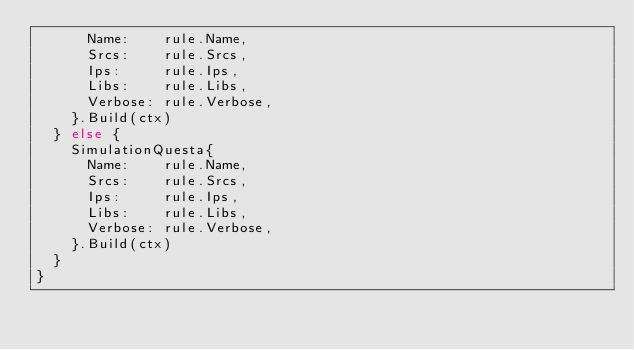Convert code to text. <code><loc_0><loc_0><loc_500><loc_500><_Go_>			Name:    rule.Name,
			Srcs:    rule.Srcs,
			Ips:     rule.Ips,
			Libs:    rule.Libs,
			Verbose: rule.Verbose,
		}.Build(ctx)
	} else {
		SimulationQuesta{
			Name:    rule.Name,
			Srcs:    rule.Srcs,
			Ips:     rule.Ips,
			Libs:    rule.Libs,
			Verbose: rule.Verbose,
		}.Build(ctx)
	}
}
</code> 